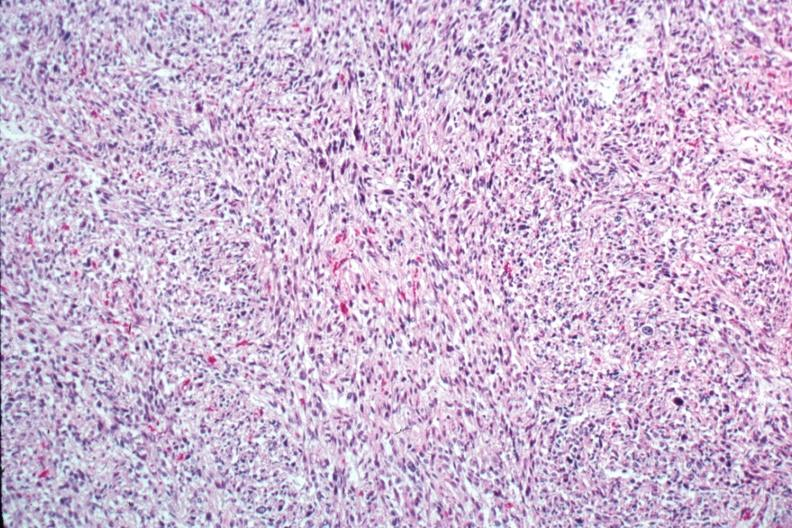s anomalous origin present?
Answer the question using a single word or phrase. No 